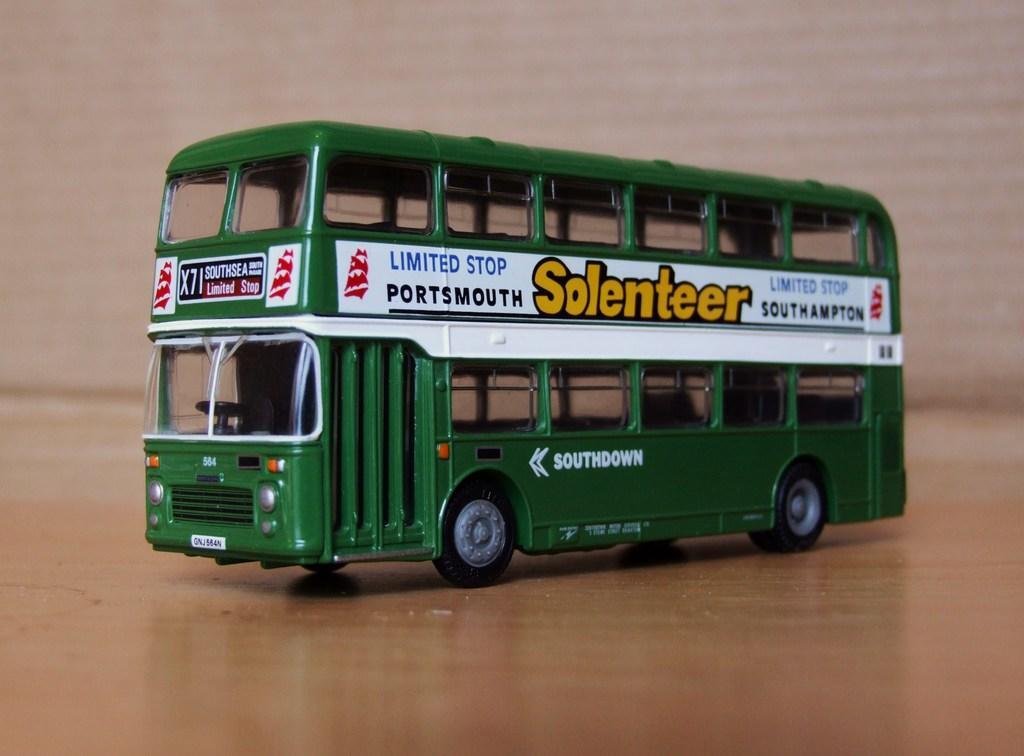Can you describe this image briefly? In this image, we can see a toy vehicle on the wooden surface. We can also see the background. 